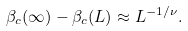Convert formula to latex. <formula><loc_0><loc_0><loc_500><loc_500>\beta _ { c } ( \infty ) - \beta _ { c } ( L ) \approx L ^ { - 1 / \nu } .</formula> 